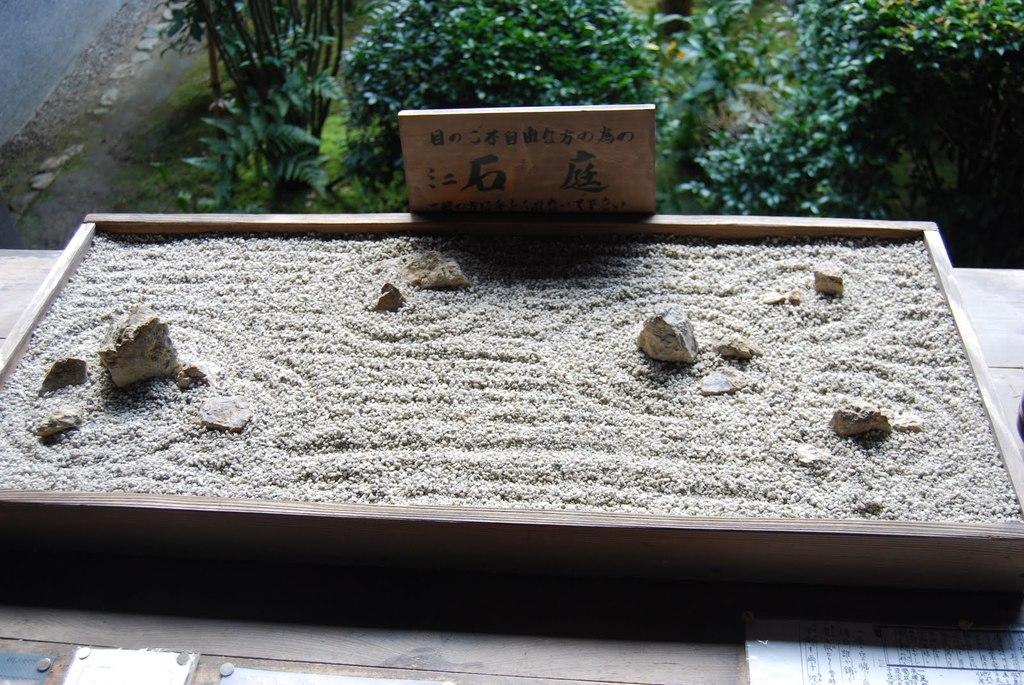Please provide a concise description of this image. In this image we can see some sand which is filled in the wooden box and there are some stones which is placed on the table and at the background of the image there are some trees and plants. 